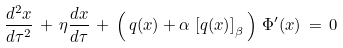<formula> <loc_0><loc_0><loc_500><loc_500>\frac { d ^ { 2 } x } { d \tau ^ { 2 } } \, + \, \eta \frac { d x } { d \tau } \, + \, \left ( \, q ( x ) + \alpha \, \left [ q ( x ) \right ] _ { \beta } \, \right ) \, \Phi ^ { \prime } ( x ) \, = \, 0</formula> 